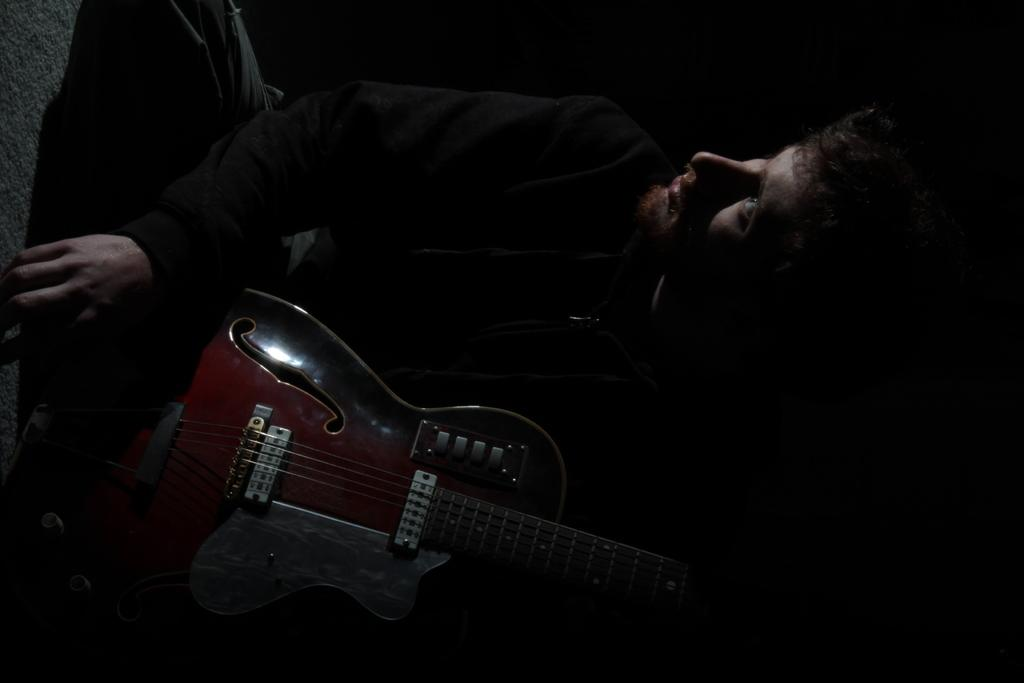Who is present in the image? There is a man in the image. What is the man doing in the image? The man is seated in the image. Can you describe the environment in the image? The man is in a dark environment. What is the man holding in the image? The man is holding a guitar. What is the opinion of the boys in the image about the north? There are no boys present in the image, and therefore no opinion about the north can be determined. 